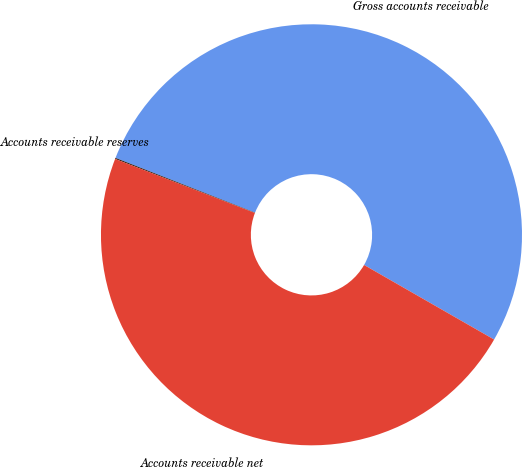Convert chart. <chart><loc_0><loc_0><loc_500><loc_500><pie_chart><fcel>Gross accounts receivable<fcel>Accounts receivable reserves<fcel>Accounts receivable net<nl><fcel>52.34%<fcel>0.08%<fcel>47.58%<nl></chart> 